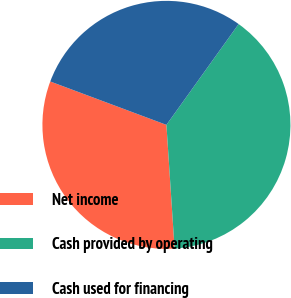Convert chart to OTSL. <chart><loc_0><loc_0><loc_500><loc_500><pie_chart><fcel>Net income<fcel>Cash provided by operating<fcel>Cash used for financing<nl><fcel>31.74%<fcel>39.06%<fcel>29.2%<nl></chart> 